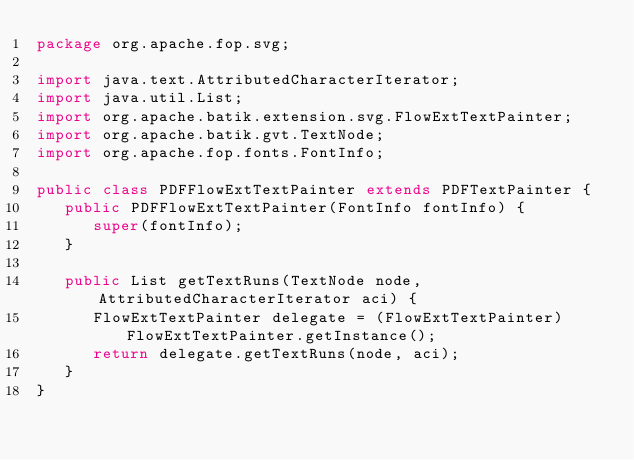Convert code to text. <code><loc_0><loc_0><loc_500><loc_500><_Java_>package org.apache.fop.svg;

import java.text.AttributedCharacterIterator;
import java.util.List;
import org.apache.batik.extension.svg.FlowExtTextPainter;
import org.apache.batik.gvt.TextNode;
import org.apache.fop.fonts.FontInfo;

public class PDFFlowExtTextPainter extends PDFTextPainter {
   public PDFFlowExtTextPainter(FontInfo fontInfo) {
      super(fontInfo);
   }

   public List getTextRuns(TextNode node, AttributedCharacterIterator aci) {
      FlowExtTextPainter delegate = (FlowExtTextPainter)FlowExtTextPainter.getInstance();
      return delegate.getTextRuns(node, aci);
   }
}
</code> 